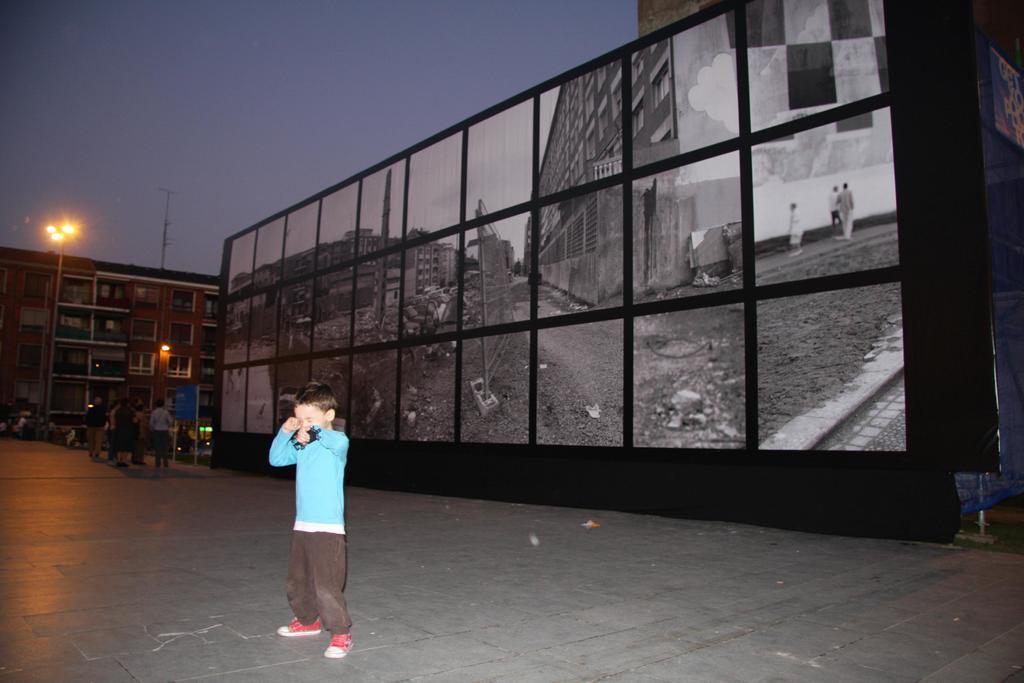How would you summarize this image in a sentence or two? There is a boy. In the back there is a wall with many saris. In the background there is a building with windows. Some people are there. There is a board with pole. There is a street light pole. And there is sky in the background. 